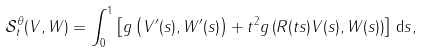Convert formula to latex. <formula><loc_0><loc_0><loc_500><loc_500>\mathcal { S } ^ { \theta } _ { t } ( V , W ) = \int _ { 0 } ^ { 1 } \left [ g \left ( V ^ { \prime } ( s ) , W ^ { \prime } ( s ) \right ) + t ^ { 2 } g \left ( R ( t s ) V ( s ) , W ( s ) \right ) \right ] \, \mathrm d s ,</formula> 